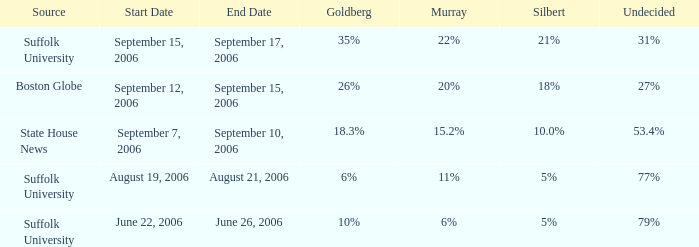When was the poll conducted in which silbert had a 10.0% rating? September 7–10, 2006. 